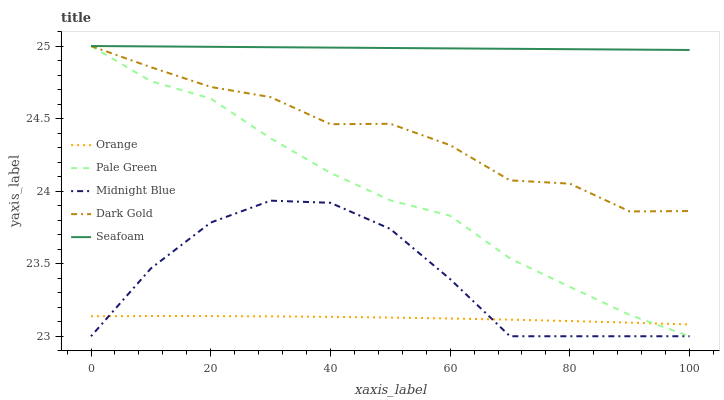Does Pale Green have the minimum area under the curve?
Answer yes or no. No. Does Pale Green have the maximum area under the curve?
Answer yes or no. No. Is Pale Green the smoothest?
Answer yes or no. No. Is Pale Green the roughest?
Answer yes or no. No. Does Seafoam have the lowest value?
Answer yes or no. No. Does Midnight Blue have the highest value?
Answer yes or no. No. Is Orange less than Dark Gold?
Answer yes or no. Yes. Is Seafoam greater than Midnight Blue?
Answer yes or no. Yes. Does Orange intersect Dark Gold?
Answer yes or no. No. 